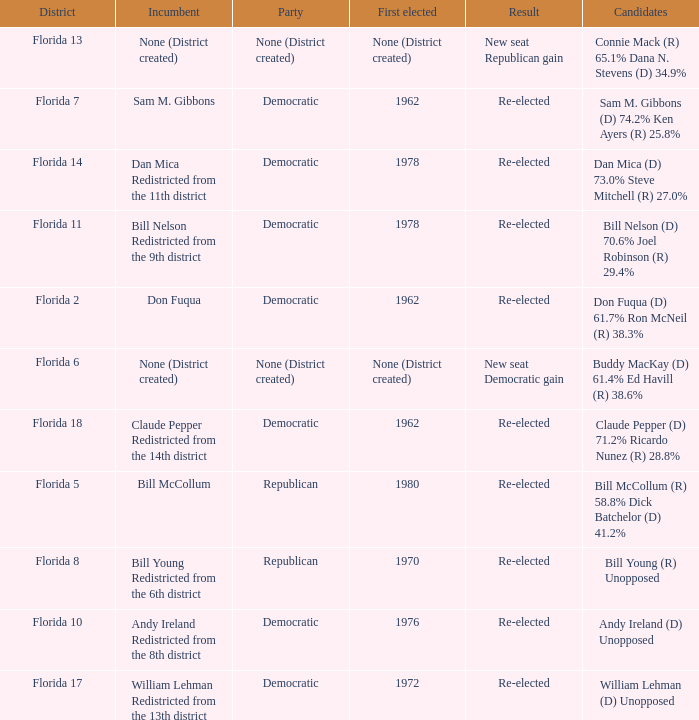Would you be able to parse every entry in this table? {'header': ['District', 'Incumbent', 'Party', 'First elected', 'Result', 'Candidates'], 'rows': [['Florida 13', 'None (District created)', 'None (District created)', 'None (District created)', 'New seat Republican gain', 'Connie Mack (R) 65.1% Dana N. Stevens (D) 34.9%'], ['Florida 7', 'Sam M. Gibbons', 'Democratic', '1962', 'Re-elected', 'Sam M. Gibbons (D) 74.2% Ken Ayers (R) 25.8%'], ['Florida 14', 'Dan Mica Redistricted from the 11th district', 'Democratic', '1978', 'Re-elected', 'Dan Mica (D) 73.0% Steve Mitchell (R) 27.0%'], ['Florida 11', 'Bill Nelson Redistricted from the 9th district', 'Democratic', '1978', 'Re-elected', 'Bill Nelson (D) 70.6% Joel Robinson (R) 29.4%'], ['Florida 2', 'Don Fuqua', 'Democratic', '1962', 'Re-elected', 'Don Fuqua (D) 61.7% Ron McNeil (R) 38.3%'], ['Florida 6', 'None (District created)', 'None (District created)', 'None (District created)', 'New seat Democratic gain', 'Buddy MacKay (D) 61.4% Ed Havill (R) 38.6%'], ['Florida 18', 'Claude Pepper Redistricted from the 14th district', 'Democratic', '1962', 'Re-elected', 'Claude Pepper (D) 71.2% Ricardo Nunez (R) 28.8%'], ['Florida 5', 'Bill McCollum', 'Republican', '1980', 'Re-elected', 'Bill McCollum (R) 58.8% Dick Batchelor (D) 41.2%'], ['Florida 8', 'Bill Young Redistricted from the 6th district', 'Republican', '1970', 'Re-elected', 'Bill Young (R) Unopposed'], ['Florida 10', 'Andy Ireland Redistricted from the 8th district', 'Democratic', '1976', 'Re-elected', 'Andy Ireland (D) Unopposed'], ['Florida 17', 'William Lehman Redistricted from the 13th district', 'Democratic', '1972', 'Re-elected', 'William Lehman (D) Unopposed']]}  how many candidates with result being new seat democratic gain 1.0. 